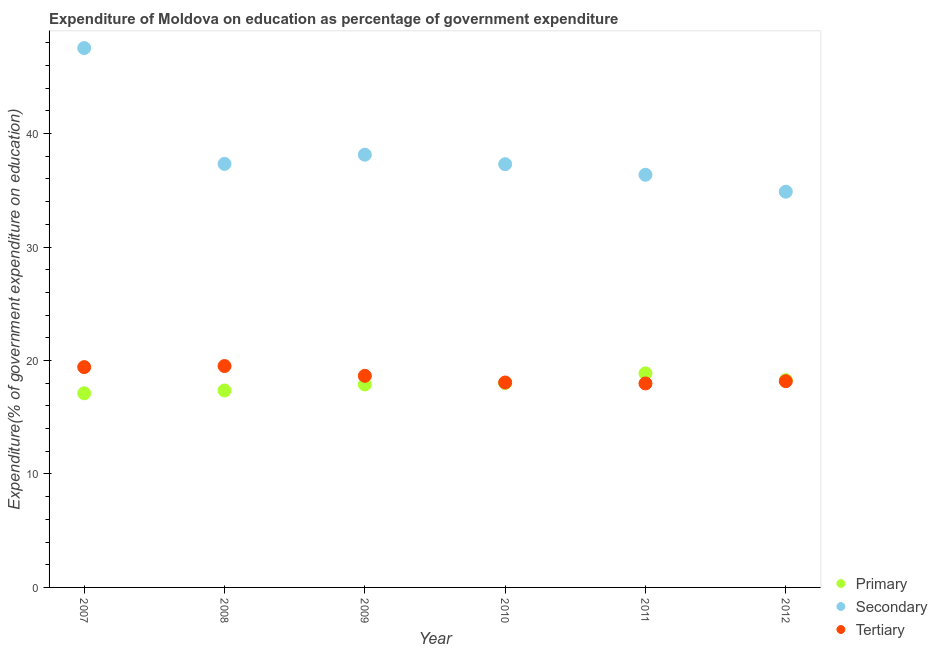What is the expenditure on tertiary education in 2008?
Your answer should be compact. 19.51. Across all years, what is the maximum expenditure on tertiary education?
Offer a very short reply. 19.51. Across all years, what is the minimum expenditure on tertiary education?
Make the answer very short. 17.98. In which year was the expenditure on secondary education maximum?
Your answer should be compact. 2007. What is the total expenditure on secondary education in the graph?
Give a very brief answer. 231.52. What is the difference between the expenditure on secondary education in 2007 and that in 2011?
Your answer should be very brief. 11.17. What is the difference between the expenditure on tertiary education in 2007 and the expenditure on secondary education in 2010?
Provide a short and direct response. -17.88. What is the average expenditure on primary education per year?
Make the answer very short. 17.92. In the year 2010, what is the difference between the expenditure on tertiary education and expenditure on secondary education?
Give a very brief answer. -19.24. What is the ratio of the expenditure on secondary education in 2008 to that in 2011?
Your answer should be compact. 1.03. What is the difference between the highest and the second highest expenditure on primary education?
Give a very brief answer. 0.6. What is the difference between the highest and the lowest expenditure on secondary education?
Your answer should be compact. 12.66. Is the sum of the expenditure on tertiary education in 2008 and 2010 greater than the maximum expenditure on secondary education across all years?
Your response must be concise. No. How many years are there in the graph?
Your response must be concise. 6. What is the difference between two consecutive major ticks on the Y-axis?
Keep it short and to the point. 10. Are the values on the major ticks of Y-axis written in scientific E-notation?
Give a very brief answer. No. Does the graph contain grids?
Provide a succinct answer. No. How are the legend labels stacked?
Your answer should be compact. Vertical. What is the title of the graph?
Your answer should be compact. Expenditure of Moldova on education as percentage of government expenditure. Does "Labor Tax" appear as one of the legend labels in the graph?
Provide a succinct answer. No. What is the label or title of the X-axis?
Your answer should be very brief. Year. What is the label or title of the Y-axis?
Offer a terse response. Expenditure(% of government expenditure on education). What is the Expenditure(% of government expenditure on education) in Primary in 2007?
Your answer should be very brief. 17.11. What is the Expenditure(% of government expenditure on education) in Secondary in 2007?
Offer a terse response. 47.53. What is the Expenditure(% of government expenditure on education) in Tertiary in 2007?
Provide a succinct answer. 19.42. What is the Expenditure(% of government expenditure on education) in Primary in 2008?
Your answer should be compact. 17.36. What is the Expenditure(% of government expenditure on education) of Secondary in 2008?
Offer a terse response. 37.32. What is the Expenditure(% of government expenditure on education) of Tertiary in 2008?
Ensure brevity in your answer.  19.51. What is the Expenditure(% of government expenditure on education) in Primary in 2009?
Your answer should be compact. 17.89. What is the Expenditure(% of government expenditure on education) of Secondary in 2009?
Ensure brevity in your answer.  38.13. What is the Expenditure(% of government expenditure on education) in Tertiary in 2009?
Ensure brevity in your answer.  18.65. What is the Expenditure(% of government expenditure on education) of Primary in 2010?
Offer a very short reply. 18.02. What is the Expenditure(% of government expenditure on education) in Secondary in 2010?
Offer a very short reply. 37.3. What is the Expenditure(% of government expenditure on education) of Tertiary in 2010?
Make the answer very short. 18.06. What is the Expenditure(% of government expenditure on education) in Primary in 2011?
Provide a succinct answer. 18.87. What is the Expenditure(% of government expenditure on education) of Secondary in 2011?
Offer a very short reply. 36.36. What is the Expenditure(% of government expenditure on education) in Tertiary in 2011?
Offer a very short reply. 17.98. What is the Expenditure(% of government expenditure on education) in Primary in 2012?
Make the answer very short. 18.27. What is the Expenditure(% of government expenditure on education) in Secondary in 2012?
Offer a terse response. 34.87. What is the Expenditure(% of government expenditure on education) in Tertiary in 2012?
Offer a terse response. 18.17. Across all years, what is the maximum Expenditure(% of government expenditure on education) of Primary?
Give a very brief answer. 18.87. Across all years, what is the maximum Expenditure(% of government expenditure on education) in Secondary?
Offer a very short reply. 47.53. Across all years, what is the maximum Expenditure(% of government expenditure on education) of Tertiary?
Your response must be concise. 19.51. Across all years, what is the minimum Expenditure(% of government expenditure on education) of Primary?
Offer a very short reply. 17.11. Across all years, what is the minimum Expenditure(% of government expenditure on education) of Secondary?
Your response must be concise. 34.87. Across all years, what is the minimum Expenditure(% of government expenditure on education) in Tertiary?
Offer a terse response. 17.98. What is the total Expenditure(% of government expenditure on education) in Primary in the graph?
Your answer should be very brief. 107.5. What is the total Expenditure(% of government expenditure on education) of Secondary in the graph?
Offer a very short reply. 231.52. What is the total Expenditure(% of government expenditure on education) of Tertiary in the graph?
Offer a terse response. 111.78. What is the difference between the Expenditure(% of government expenditure on education) of Primary in 2007 and that in 2008?
Your answer should be very brief. -0.25. What is the difference between the Expenditure(% of government expenditure on education) in Secondary in 2007 and that in 2008?
Give a very brief answer. 10.21. What is the difference between the Expenditure(% of government expenditure on education) in Tertiary in 2007 and that in 2008?
Ensure brevity in your answer.  -0.09. What is the difference between the Expenditure(% of government expenditure on education) in Primary in 2007 and that in 2009?
Keep it short and to the point. -0.77. What is the difference between the Expenditure(% of government expenditure on education) in Secondary in 2007 and that in 2009?
Provide a short and direct response. 9.4. What is the difference between the Expenditure(% of government expenditure on education) in Tertiary in 2007 and that in 2009?
Your answer should be very brief. 0.77. What is the difference between the Expenditure(% of government expenditure on education) of Primary in 2007 and that in 2010?
Keep it short and to the point. -0.91. What is the difference between the Expenditure(% of government expenditure on education) in Secondary in 2007 and that in 2010?
Offer a terse response. 10.23. What is the difference between the Expenditure(% of government expenditure on education) of Tertiary in 2007 and that in 2010?
Ensure brevity in your answer.  1.36. What is the difference between the Expenditure(% of government expenditure on education) in Primary in 2007 and that in 2011?
Your answer should be compact. -1.75. What is the difference between the Expenditure(% of government expenditure on education) of Secondary in 2007 and that in 2011?
Keep it short and to the point. 11.16. What is the difference between the Expenditure(% of government expenditure on education) in Tertiary in 2007 and that in 2011?
Ensure brevity in your answer.  1.44. What is the difference between the Expenditure(% of government expenditure on education) in Primary in 2007 and that in 2012?
Your answer should be compact. -1.16. What is the difference between the Expenditure(% of government expenditure on education) of Secondary in 2007 and that in 2012?
Give a very brief answer. 12.66. What is the difference between the Expenditure(% of government expenditure on education) of Tertiary in 2007 and that in 2012?
Make the answer very short. 1.24. What is the difference between the Expenditure(% of government expenditure on education) in Primary in 2008 and that in 2009?
Your response must be concise. -0.53. What is the difference between the Expenditure(% of government expenditure on education) in Secondary in 2008 and that in 2009?
Make the answer very short. -0.81. What is the difference between the Expenditure(% of government expenditure on education) in Tertiary in 2008 and that in 2009?
Ensure brevity in your answer.  0.86. What is the difference between the Expenditure(% of government expenditure on education) of Primary in 2008 and that in 2010?
Your answer should be very brief. -0.66. What is the difference between the Expenditure(% of government expenditure on education) in Secondary in 2008 and that in 2010?
Provide a succinct answer. 0.03. What is the difference between the Expenditure(% of government expenditure on education) in Tertiary in 2008 and that in 2010?
Offer a very short reply. 1.45. What is the difference between the Expenditure(% of government expenditure on education) in Primary in 2008 and that in 2011?
Offer a very short reply. -1.51. What is the difference between the Expenditure(% of government expenditure on education) in Secondary in 2008 and that in 2011?
Ensure brevity in your answer.  0.96. What is the difference between the Expenditure(% of government expenditure on education) in Tertiary in 2008 and that in 2011?
Your response must be concise. 1.53. What is the difference between the Expenditure(% of government expenditure on education) of Primary in 2008 and that in 2012?
Give a very brief answer. -0.91. What is the difference between the Expenditure(% of government expenditure on education) of Secondary in 2008 and that in 2012?
Ensure brevity in your answer.  2.45. What is the difference between the Expenditure(% of government expenditure on education) in Tertiary in 2008 and that in 2012?
Keep it short and to the point. 1.34. What is the difference between the Expenditure(% of government expenditure on education) in Primary in 2009 and that in 2010?
Offer a terse response. -0.13. What is the difference between the Expenditure(% of government expenditure on education) of Secondary in 2009 and that in 2010?
Ensure brevity in your answer.  0.84. What is the difference between the Expenditure(% of government expenditure on education) of Tertiary in 2009 and that in 2010?
Provide a short and direct response. 0.59. What is the difference between the Expenditure(% of government expenditure on education) in Primary in 2009 and that in 2011?
Your answer should be compact. -0.98. What is the difference between the Expenditure(% of government expenditure on education) in Secondary in 2009 and that in 2011?
Offer a terse response. 1.77. What is the difference between the Expenditure(% of government expenditure on education) in Tertiary in 2009 and that in 2011?
Give a very brief answer. 0.67. What is the difference between the Expenditure(% of government expenditure on education) of Primary in 2009 and that in 2012?
Ensure brevity in your answer.  -0.38. What is the difference between the Expenditure(% of government expenditure on education) of Secondary in 2009 and that in 2012?
Provide a short and direct response. 3.26. What is the difference between the Expenditure(% of government expenditure on education) in Tertiary in 2009 and that in 2012?
Offer a terse response. 0.47. What is the difference between the Expenditure(% of government expenditure on education) of Primary in 2010 and that in 2011?
Your answer should be very brief. -0.85. What is the difference between the Expenditure(% of government expenditure on education) in Secondary in 2010 and that in 2011?
Your answer should be compact. 0.93. What is the difference between the Expenditure(% of government expenditure on education) of Tertiary in 2010 and that in 2011?
Your response must be concise. 0.08. What is the difference between the Expenditure(% of government expenditure on education) of Primary in 2010 and that in 2012?
Your answer should be compact. -0.25. What is the difference between the Expenditure(% of government expenditure on education) of Secondary in 2010 and that in 2012?
Your answer should be very brief. 2.42. What is the difference between the Expenditure(% of government expenditure on education) of Tertiary in 2010 and that in 2012?
Provide a short and direct response. -0.12. What is the difference between the Expenditure(% of government expenditure on education) in Primary in 2011 and that in 2012?
Offer a terse response. 0.6. What is the difference between the Expenditure(% of government expenditure on education) in Secondary in 2011 and that in 2012?
Make the answer very short. 1.49. What is the difference between the Expenditure(% of government expenditure on education) in Tertiary in 2011 and that in 2012?
Give a very brief answer. -0.2. What is the difference between the Expenditure(% of government expenditure on education) of Primary in 2007 and the Expenditure(% of government expenditure on education) of Secondary in 2008?
Provide a short and direct response. -20.21. What is the difference between the Expenditure(% of government expenditure on education) of Primary in 2007 and the Expenditure(% of government expenditure on education) of Tertiary in 2008?
Your response must be concise. -2.4. What is the difference between the Expenditure(% of government expenditure on education) of Secondary in 2007 and the Expenditure(% of government expenditure on education) of Tertiary in 2008?
Provide a succinct answer. 28.02. What is the difference between the Expenditure(% of government expenditure on education) in Primary in 2007 and the Expenditure(% of government expenditure on education) in Secondary in 2009?
Make the answer very short. -21.02. What is the difference between the Expenditure(% of government expenditure on education) in Primary in 2007 and the Expenditure(% of government expenditure on education) in Tertiary in 2009?
Your answer should be compact. -1.53. What is the difference between the Expenditure(% of government expenditure on education) of Secondary in 2007 and the Expenditure(% of government expenditure on education) of Tertiary in 2009?
Make the answer very short. 28.88. What is the difference between the Expenditure(% of government expenditure on education) in Primary in 2007 and the Expenditure(% of government expenditure on education) in Secondary in 2010?
Provide a succinct answer. -20.19. What is the difference between the Expenditure(% of government expenditure on education) of Primary in 2007 and the Expenditure(% of government expenditure on education) of Tertiary in 2010?
Offer a very short reply. -0.95. What is the difference between the Expenditure(% of government expenditure on education) of Secondary in 2007 and the Expenditure(% of government expenditure on education) of Tertiary in 2010?
Keep it short and to the point. 29.47. What is the difference between the Expenditure(% of government expenditure on education) of Primary in 2007 and the Expenditure(% of government expenditure on education) of Secondary in 2011?
Offer a terse response. -19.25. What is the difference between the Expenditure(% of government expenditure on education) of Primary in 2007 and the Expenditure(% of government expenditure on education) of Tertiary in 2011?
Ensure brevity in your answer.  -0.87. What is the difference between the Expenditure(% of government expenditure on education) of Secondary in 2007 and the Expenditure(% of government expenditure on education) of Tertiary in 2011?
Provide a short and direct response. 29.55. What is the difference between the Expenditure(% of government expenditure on education) in Primary in 2007 and the Expenditure(% of government expenditure on education) in Secondary in 2012?
Offer a terse response. -17.76. What is the difference between the Expenditure(% of government expenditure on education) of Primary in 2007 and the Expenditure(% of government expenditure on education) of Tertiary in 2012?
Provide a succinct answer. -1.06. What is the difference between the Expenditure(% of government expenditure on education) in Secondary in 2007 and the Expenditure(% of government expenditure on education) in Tertiary in 2012?
Your response must be concise. 29.36. What is the difference between the Expenditure(% of government expenditure on education) in Primary in 2008 and the Expenditure(% of government expenditure on education) in Secondary in 2009?
Keep it short and to the point. -20.78. What is the difference between the Expenditure(% of government expenditure on education) in Primary in 2008 and the Expenditure(% of government expenditure on education) in Tertiary in 2009?
Give a very brief answer. -1.29. What is the difference between the Expenditure(% of government expenditure on education) of Secondary in 2008 and the Expenditure(% of government expenditure on education) of Tertiary in 2009?
Ensure brevity in your answer.  18.68. What is the difference between the Expenditure(% of government expenditure on education) in Primary in 2008 and the Expenditure(% of government expenditure on education) in Secondary in 2010?
Your answer should be compact. -19.94. What is the difference between the Expenditure(% of government expenditure on education) of Primary in 2008 and the Expenditure(% of government expenditure on education) of Tertiary in 2010?
Make the answer very short. -0.7. What is the difference between the Expenditure(% of government expenditure on education) in Secondary in 2008 and the Expenditure(% of government expenditure on education) in Tertiary in 2010?
Provide a succinct answer. 19.26. What is the difference between the Expenditure(% of government expenditure on education) in Primary in 2008 and the Expenditure(% of government expenditure on education) in Secondary in 2011?
Your response must be concise. -19.01. What is the difference between the Expenditure(% of government expenditure on education) of Primary in 2008 and the Expenditure(% of government expenditure on education) of Tertiary in 2011?
Your response must be concise. -0.62. What is the difference between the Expenditure(% of government expenditure on education) in Secondary in 2008 and the Expenditure(% of government expenditure on education) in Tertiary in 2011?
Provide a short and direct response. 19.35. What is the difference between the Expenditure(% of government expenditure on education) of Primary in 2008 and the Expenditure(% of government expenditure on education) of Secondary in 2012?
Keep it short and to the point. -17.52. What is the difference between the Expenditure(% of government expenditure on education) in Primary in 2008 and the Expenditure(% of government expenditure on education) in Tertiary in 2012?
Your answer should be compact. -0.82. What is the difference between the Expenditure(% of government expenditure on education) of Secondary in 2008 and the Expenditure(% of government expenditure on education) of Tertiary in 2012?
Provide a succinct answer. 19.15. What is the difference between the Expenditure(% of government expenditure on education) in Primary in 2009 and the Expenditure(% of government expenditure on education) in Secondary in 2010?
Provide a short and direct response. -19.41. What is the difference between the Expenditure(% of government expenditure on education) of Primary in 2009 and the Expenditure(% of government expenditure on education) of Tertiary in 2010?
Offer a very short reply. -0.17. What is the difference between the Expenditure(% of government expenditure on education) of Secondary in 2009 and the Expenditure(% of government expenditure on education) of Tertiary in 2010?
Keep it short and to the point. 20.07. What is the difference between the Expenditure(% of government expenditure on education) in Primary in 2009 and the Expenditure(% of government expenditure on education) in Secondary in 2011?
Offer a very short reply. -18.48. What is the difference between the Expenditure(% of government expenditure on education) of Primary in 2009 and the Expenditure(% of government expenditure on education) of Tertiary in 2011?
Keep it short and to the point. -0.09. What is the difference between the Expenditure(% of government expenditure on education) of Secondary in 2009 and the Expenditure(% of government expenditure on education) of Tertiary in 2011?
Offer a very short reply. 20.16. What is the difference between the Expenditure(% of government expenditure on education) of Primary in 2009 and the Expenditure(% of government expenditure on education) of Secondary in 2012?
Offer a terse response. -16.99. What is the difference between the Expenditure(% of government expenditure on education) in Primary in 2009 and the Expenditure(% of government expenditure on education) in Tertiary in 2012?
Your answer should be compact. -0.29. What is the difference between the Expenditure(% of government expenditure on education) of Secondary in 2009 and the Expenditure(% of government expenditure on education) of Tertiary in 2012?
Give a very brief answer. 19.96. What is the difference between the Expenditure(% of government expenditure on education) of Primary in 2010 and the Expenditure(% of government expenditure on education) of Secondary in 2011?
Provide a succinct answer. -18.35. What is the difference between the Expenditure(% of government expenditure on education) of Primary in 2010 and the Expenditure(% of government expenditure on education) of Tertiary in 2011?
Your answer should be very brief. 0.04. What is the difference between the Expenditure(% of government expenditure on education) in Secondary in 2010 and the Expenditure(% of government expenditure on education) in Tertiary in 2011?
Provide a short and direct response. 19.32. What is the difference between the Expenditure(% of government expenditure on education) of Primary in 2010 and the Expenditure(% of government expenditure on education) of Secondary in 2012?
Provide a short and direct response. -16.86. What is the difference between the Expenditure(% of government expenditure on education) of Primary in 2010 and the Expenditure(% of government expenditure on education) of Tertiary in 2012?
Provide a short and direct response. -0.16. What is the difference between the Expenditure(% of government expenditure on education) of Secondary in 2010 and the Expenditure(% of government expenditure on education) of Tertiary in 2012?
Keep it short and to the point. 19.12. What is the difference between the Expenditure(% of government expenditure on education) in Primary in 2011 and the Expenditure(% of government expenditure on education) in Secondary in 2012?
Your answer should be compact. -16.01. What is the difference between the Expenditure(% of government expenditure on education) in Primary in 2011 and the Expenditure(% of government expenditure on education) in Tertiary in 2012?
Keep it short and to the point. 0.69. What is the difference between the Expenditure(% of government expenditure on education) in Secondary in 2011 and the Expenditure(% of government expenditure on education) in Tertiary in 2012?
Make the answer very short. 18.19. What is the average Expenditure(% of government expenditure on education) of Primary per year?
Provide a short and direct response. 17.92. What is the average Expenditure(% of government expenditure on education) in Secondary per year?
Offer a very short reply. 38.59. What is the average Expenditure(% of government expenditure on education) of Tertiary per year?
Keep it short and to the point. 18.63. In the year 2007, what is the difference between the Expenditure(% of government expenditure on education) in Primary and Expenditure(% of government expenditure on education) in Secondary?
Ensure brevity in your answer.  -30.42. In the year 2007, what is the difference between the Expenditure(% of government expenditure on education) of Primary and Expenditure(% of government expenditure on education) of Tertiary?
Offer a very short reply. -2.3. In the year 2007, what is the difference between the Expenditure(% of government expenditure on education) in Secondary and Expenditure(% of government expenditure on education) in Tertiary?
Give a very brief answer. 28.11. In the year 2008, what is the difference between the Expenditure(% of government expenditure on education) in Primary and Expenditure(% of government expenditure on education) in Secondary?
Provide a succinct answer. -19.97. In the year 2008, what is the difference between the Expenditure(% of government expenditure on education) of Primary and Expenditure(% of government expenditure on education) of Tertiary?
Your answer should be compact. -2.15. In the year 2008, what is the difference between the Expenditure(% of government expenditure on education) of Secondary and Expenditure(% of government expenditure on education) of Tertiary?
Provide a short and direct response. 17.81. In the year 2009, what is the difference between the Expenditure(% of government expenditure on education) in Primary and Expenditure(% of government expenditure on education) in Secondary?
Make the answer very short. -20.25. In the year 2009, what is the difference between the Expenditure(% of government expenditure on education) in Primary and Expenditure(% of government expenditure on education) in Tertiary?
Keep it short and to the point. -0.76. In the year 2009, what is the difference between the Expenditure(% of government expenditure on education) in Secondary and Expenditure(% of government expenditure on education) in Tertiary?
Keep it short and to the point. 19.49. In the year 2010, what is the difference between the Expenditure(% of government expenditure on education) in Primary and Expenditure(% of government expenditure on education) in Secondary?
Your answer should be compact. -19.28. In the year 2010, what is the difference between the Expenditure(% of government expenditure on education) of Primary and Expenditure(% of government expenditure on education) of Tertiary?
Make the answer very short. -0.04. In the year 2010, what is the difference between the Expenditure(% of government expenditure on education) of Secondary and Expenditure(% of government expenditure on education) of Tertiary?
Offer a very short reply. 19.24. In the year 2011, what is the difference between the Expenditure(% of government expenditure on education) in Primary and Expenditure(% of government expenditure on education) in Secondary?
Offer a terse response. -17.5. In the year 2011, what is the difference between the Expenditure(% of government expenditure on education) of Primary and Expenditure(% of government expenditure on education) of Tertiary?
Provide a succinct answer. 0.89. In the year 2011, what is the difference between the Expenditure(% of government expenditure on education) of Secondary and Expenditure(% of government expenditure on education) of Tertiary?
Keep it short and to the point. 18.39. In the year 2012, what is the difference between the Expenditure(% of government expenditure on education) of Primary and Expenditure(% of government expenditure on education) of Secondary?
Provide a short and direct response. -16.61. In the year 2012, what is the difference between the Expenditure(% of government expenditure on education) of Primary and Expenditure(% of government expenditure on education) of Tertiary?
Provide a succinct answer. 0.09. In the year 2012, what is the difference between the Expenditure(% of government expenditure on education) in Secondary and Expenditure(% of government expenditure on education) in Tertiary?
Give a very brief answer. 16.7. What is the ratio of the Expenditure(% of government expenditure on education) of Primary in 2007 to that in 2008?
Make the answer very short. 0.99. What is the ratio of the Expenditure(% of government expenditure on education) in Secondary in 2007 to that in 2008?
Your answer should be very brief. 1.27. What is the ratio of the Expenditure(% of government expenditure on education) in Primary in 2007 to that in 2009?
Your answer should be compact. 0.96. What is the ratio of the Expenditure(% of government expenditure on education) in Secondary in 2007 to that in 2009?
Provide a short and direct response. 1.25. What is the ratio of the Expenditure(% of government expenditure on education) of Tertiary in 2007 to that in 2009?
Ensure brevity in your answer.  1.04. What is the ratio of the Expenditure(% of government expenditure on education) of Primary in 2007 to that in 2010?
Your answer should be compact. 0.95. What is the ratio of the Expenditure(% of government expenditure on education) of Secondary in 2007 to that in 2010?
Offer a very short reply. 1.27. What is the ratio of the Expenditure(% of government expenditure on education) in Tertiary in 2007 to that in 2010?
Offer a terse response. 1.08. What is the ratio of the Expenditure(% of government expenditure on education) in Primary in 2007 to that in 2011?
Keep it short and to the point. 0.91. What is the ratio of the Expenditure(% of government expenditure on education) in Secondary in 2007 to that in 2011?
Provide a short and direct response. 1.31. What is the ratio of the Expenditure(% of government expenditure on education) of Tertiary in 2007 to that in 2011?
Make the answer very short. 1.08. What is the ratio of the Expenditure(% of government expenditure on education) in Primary in 2007 to that in 2012?
Ensure brevity in your answer.  0.94. What is the ratio of the Expenditure(% of government expenditure on education) in Secondary in 2007 to that in 2012?
Keep it short and to the point. 1.36. What is the ratio of the Expenditure(% of government expenditure on education) of Tertiary in 2007 to that in 2012?
Your answer should be very brief. 1.07. What is the ratio of the Expenditure(% of government expenditure on education) in Primary in 2008 to that in 2009?
Your response must be concise. 0.97. What is the ratio of the Expenditure(% of government expenditure on education) of Secondary in 2008 to that in 2009?
Provide a short and direct response. 0.98. What is the ratio of the Expenditure(% of government expenditure on education) in Tertiary in 2008 to that in 2009?
Keep it short and to the point. 1.05. What is the ratio of the Expenditure(% of government expenditure on education) in Primary in 2008 to that in 2010?
Your answer should be compact. 0.96. What is the ratio of the Expenditure(% of government expenditure on education) of Tertiary in 2008 to that in 2010?
Keep it short and to the point. 1.08. What is the ratio of the Expenditure(% of government expenditure on education) in Secondary in 2008 to that in 2011?
Provide a succinct answer. 1.03. What is the ratio of the Expenditure(% of government expenditure on education) in Tertiary in 2008 to that in 2011?
Keep it short and to the point. 1.09. What is the ratio of the Expenditure(% of government expenditure on education) in Primary in 2008 to that in 2012?
Give a very brief answer. 0.95. What is the ratio of the Expenditure(% of government expenditure on education) of Secondary in 2008 to that in 2012?
Your answer should be compact. 1.07. What is the ratio of the Expenditure(% of government expenditure on education) of Tertiary in 2008 to that in 2012?
Give a very brief answer. 1.07. What is the ratio of the Expenditure(% of government expenditure on education) in Primary in 2009 to that in 2010?
Keep it short and to the point. 0.99. What is the ratio of the Expenditure(% of government expenditure on education) of Secondary in 2009 to that in 2010?
Keep it short and to the point. 1.02. What is the ratio of the Expenditure(% of government expenditure on education) in Tertiary in 2009 to that in 2010?
Provide a short and direct response. 1.03. What is the ratio of the Expenditure(% of government expenditure on education) of Primary in 2009 to that in 2011?
Your answer should be very brief. 0.95. What is the ratio of the Expenditure(% of government expenditure on education) of Secondary in 2009 to that in 2011?
Your answer should be very brief. 1.05. What is the ratio of the Expenditure(% of government expenditure on education) in Tertiary in 2009 to that in 2011?
Provide a succinct answer. 1.04. What is the ratio of the Expenditure(% of government expenditure on education) in Primary in 2009 to that in 2012?
Your answer should be very brief. 0.98. What is the ratio of the Expenditure(% of government expenditure on education) of Secondary in 2009 to that in 2012?
Offer a terse response. 1.09. What is the ratio of the Expenditure(% of government expenditure on education) in Tertiary in 2009 to that in 2012?
Ensure brevity in your answer.  1.03. What is the ratio of the Expenditure(% of government expenditure on education) in Primary in 2010 to that in 2011?
Your response must be concise. 0.96. What is the ratio of the Expenditure(% of government expenditure on education) of Secondary in 2010 to that in 2011?
Ensure brevity in your answer.  1.03. What is the ratio of the Expenditure(% of government expenditure on education) in Primary in 2010 to that in 2012?
Offer a very short reply. 0.99. What is the ratio of the Expenditure(% of government expenditure on education) of Secondary in 2010 to that in 2012?
Offer a terse response. 1.07. What is the ratio of the Expenditure(% of government expenditure on education) in Primary in 2011 to that in 2012?
Give a very brief answer. 1.03. What is the ratio of the Expenditure(% of government expenditure on education) of Secondary in 2011 to that in 2012?
Provide a short and direct response. 1.04. What is the ratio of the Expenditure(% of government expenditure on education) of Tertiary in 2011 to that in 2012?
Your answer should be compact. 0.99. What is the difference between the highest and the second highest Expenditure(% of government expenditure on education) in Primary?
Make the answer very short. 0.6. What is the difference between the highest and the second highest Expenditure(% of government expenditure on education) of Secondary?
Offer a very short reply. 9.4. What is the difference between the highest and the second highest Expenditure(% of government expenditure on education) of Tertiary?
Provide a succinct answer. 0.09. What is the difference between the highest and the lowest Expenditure(% of government expenditure on education) in Primary?
Ensure brevity in your answer.  1.75. What is the difference between the highest and the lowest Expenditure(% of government expenditure on education) of Secondary?
Offer a very short reply. 12.66. What is the difference between the highest and the lowest Expenditure(% of government expenditure on education) of Tertiary?
Provide a short and direct response. 1.53. 